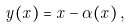Convert formula to latex. <formula><loc_0><loc_0><loc_500><loc_500>\vec { y } ( \vec { x } ) = \vec { x } - \vec { \alpha } ( \vec { x } ) \, ,</formula> 